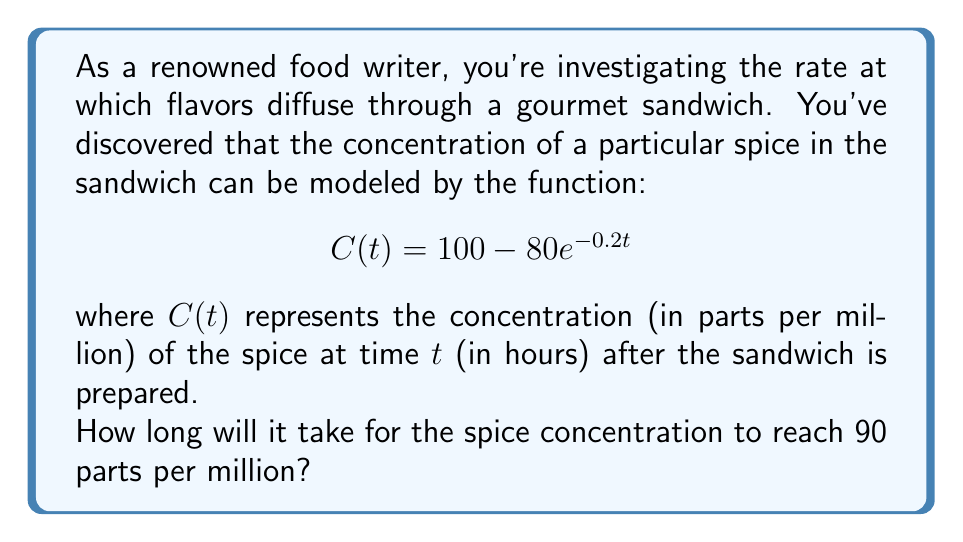Provide a solution to this math problem. To solve this problem, we need to follow these steps:

1) We're looking for the time $t$ when the concentration $C(t)$ equals 90 ppm. So, we need to solve the equation:

   $$90 = 100 - 80e^{-0.2t}$$

2) Subtract 100 from both sides:

   $$-10 = -80e^{-0.2t}$$

3) Divide both sides by -80:

   $$\frac{1}{8} = e^{-0.2t}$$

4) Take the natural logarithm of both sides:

   $$\ln(\frac{1}{8}) = \ln(e^{-0.2t})$$

5) Simplify the right side using the properties of logarithms:

   $$\ln(\frac{1}{8}) = -0.2t$$

6) Calculate $\ln(\frac{1}{8})$:

   $$-2.0794 = -0.2t$$

7) Divide both sides by -0.2:

   $$\frac{-2.0794}{-0.2} = t$$

8) Calculate the final result:

   $$10.397 = t$$

Therefore, it will take approximately 10.397 hours for the spice concentration to reach 90 parts per million.
Answer: 10.397 hours 